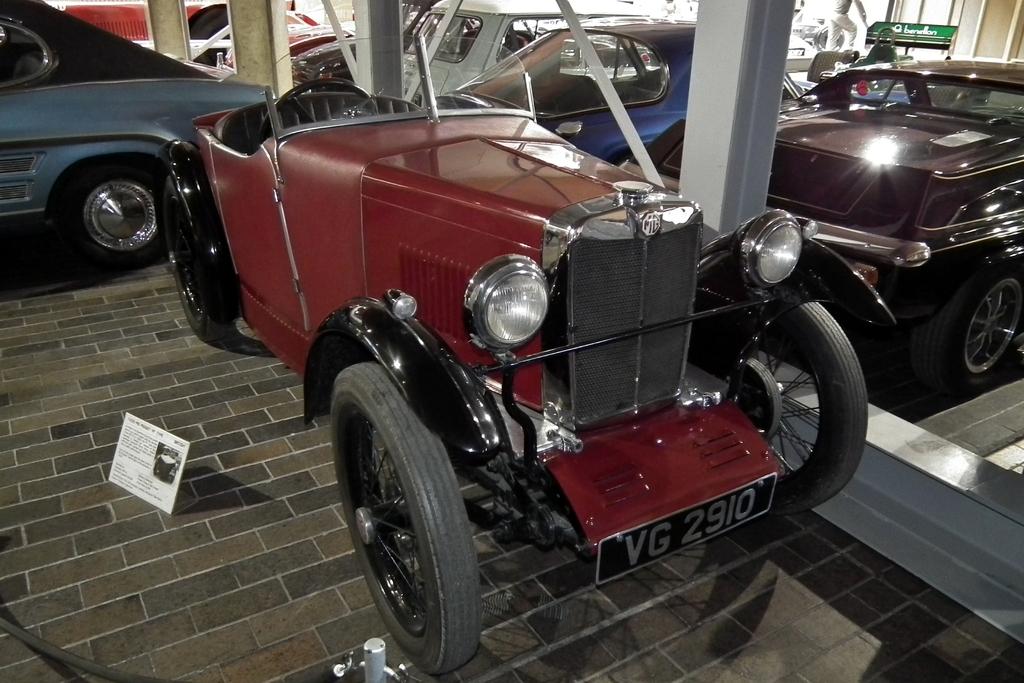What is the plate number?
Give a very brief answer. Vg 2910. 